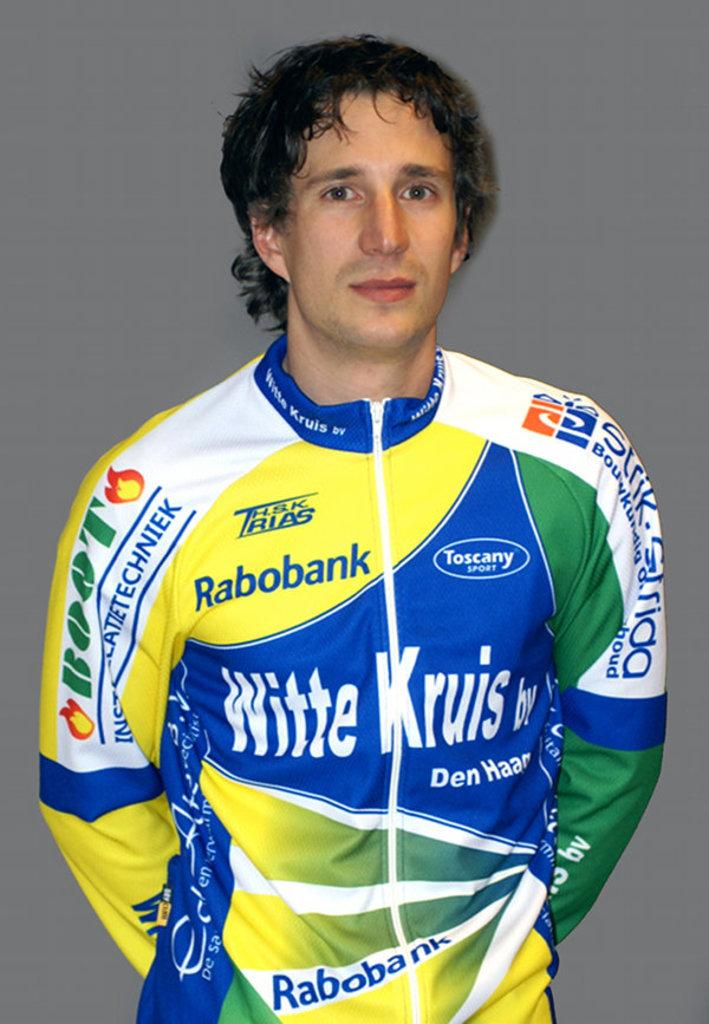<image>
Write a terse but informative summary of the picture. Man wearing a jersey which says "Rabobank" on it. 